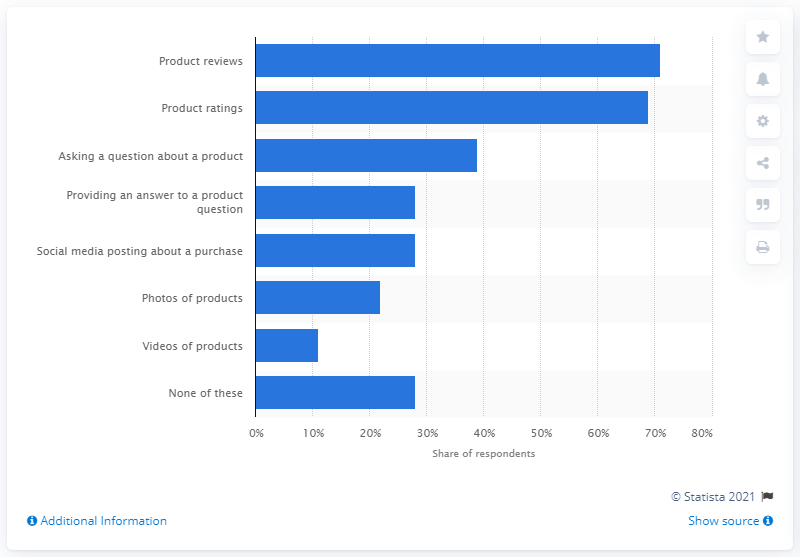Identify some key points in this picture. Seventy-one percent of the product reviews submitted to UCG were the most popular. 